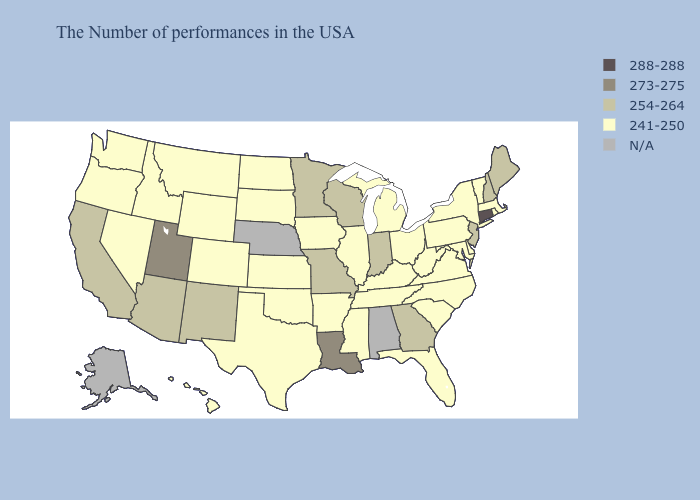Does Minnesota have the lowest value in the MidWest?
Write a very short answer. No. Does the map have missing data?
Concise answer only. Yes. What is the value of New Mexico?
Give a very brief answer. 254-264. What is the value of North Dakota?
Short answer required. 241-250. Does the map have missing data?
Concise answer only. Yes. What is the value of Louisiana?
Give a very brief answer. 273-275. Among the states that border Illinois , does Missouri have the highest value?
Give a very brief answer. Yes. Which states hav the highest value in the West?
Be succinct. Utah. What is the value of Maine?
Give a very brief answer. 254-264. What is the value of Hawaii?
Give a very brief answer. 241-250. Does Connecticut have the highest value in the Northeast?
Quick response, please. Yes. Name the states that have a value in the range 288-288?
Concise answer only. Connecticut. Which states have the lowest value in the USA?
Quick response, please. Massachusetts, Rhode Island, Vermont, New York, Delaware, Maryland, Pennsylvania, Virginia, North Carolina, South Carolina, West Virginia, Ohio, Florida, Michigan, Kentucky, Tennessee, Illinois, Mississippi, Arkansas, Iowa, Kansas, Oklahoma, Texas, South Dakota, North Dakota, Wyoming, Colorado, Montana, Idaho, Nevada, Washington, Oregon, Hawaii. Does Idaho have the highest value in the USA?
Short answer required. No. 